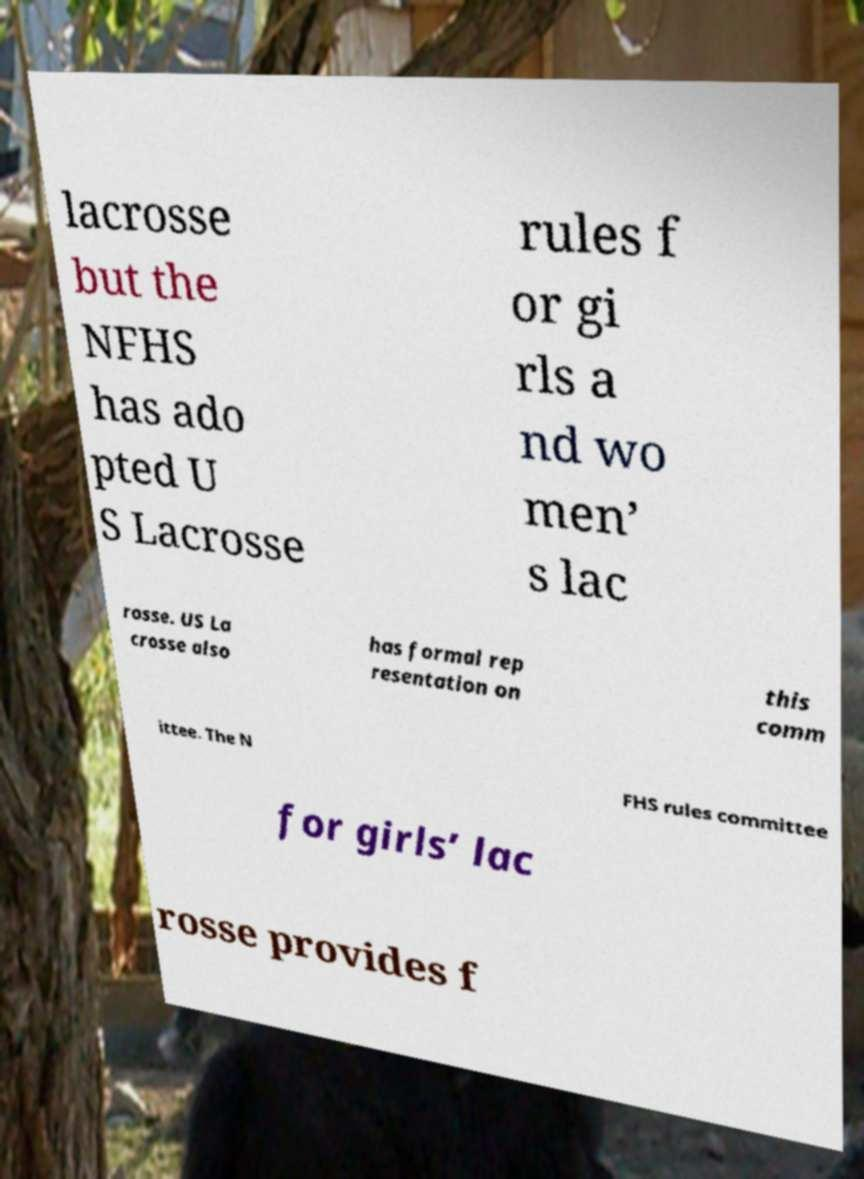Please identify and transcribe the text found in this image. lacrosse but the NFHS has ado pted U S Lacrosse rules f or gi rls a nd wo men’ s lac rosse. US La crosse also has formal rep resentation on this comm ittee. The N FHS rules committee for girls’ lac rosse provides f 